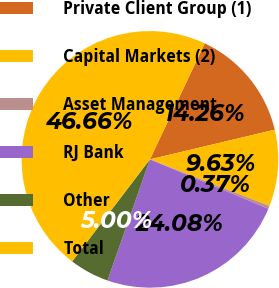<chart> <loc_0><loc_0><loc_500><loc_500><pie_chart><fcel>Private Client Group (1)<fcel>Capital Markets (2)<fcel>Asset Management<fcel>RJ Bank<fcel>Other<fcel>Total<nl><fcel>14.26%<fcel>9.63%<fcel>0.37%<fcel>24.08%<fcel>5.0%<fcel>46.66%<nl></chart> 